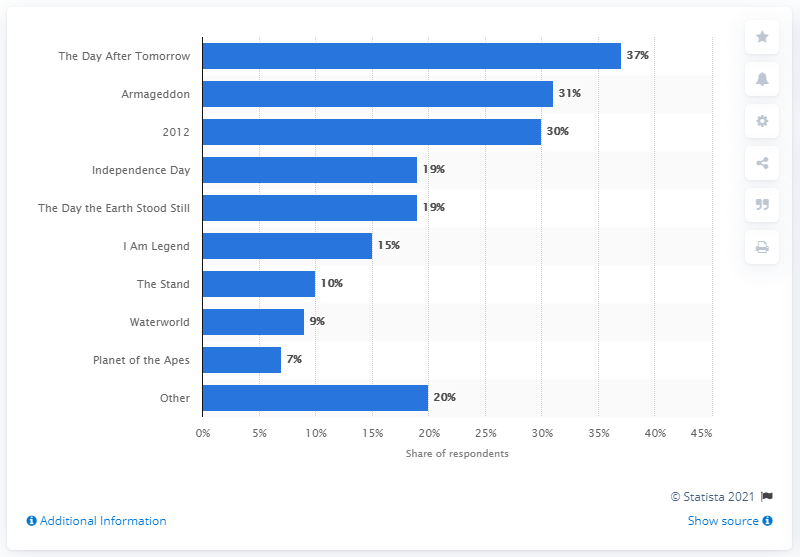Mention a couple of crucial points in this snapshot. A survey was conducted to determine which movie depicts events that could happen in the next 25 years. Seven percent of respondents answered that "Planet of the Apes" does so. 